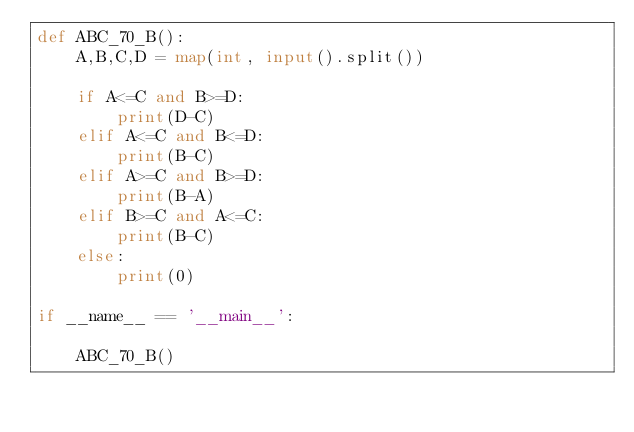<code> <loc_0><loc_0><loc_500><loc_500><_Python_>def ABC_70_B():
    A,B,C,D = map(int, input().split())

    if A<=C and B>=D:
        print(D-C)
    elif A<=C and B<=D:
        print(B-C)
    elif A>=C and B>=D:
        print(B-A)
    elif B>=C and A<=C:
        print(B-C)
    else:
        print(0)

if __name__ == '__main__':

    ABC_70_B()</code> 